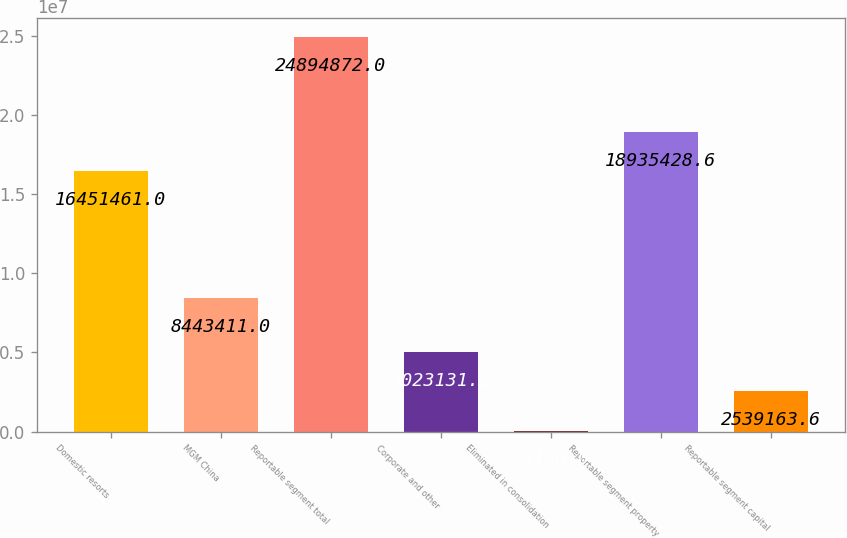Convert chart to OTSL. <chart><loc_0><loc_0><loc_500><loc_500><bar_chart><fcel>Domestic resorts<fcel>MGM China<fcel>Reportable segment total<fcel>Corporate and other<fcel>Eliminated in consolidation<fcel>Reportable segment property<fcel>Reportable segment capital<nl><fcel>1.64515e+07<fcel>8.44341e+06<fcel>2.48949e+07<fcel>5.02313e+06<fcel>55196<fcel>1.89354e+07<fcel>2.53916e+06<nl></chart> 